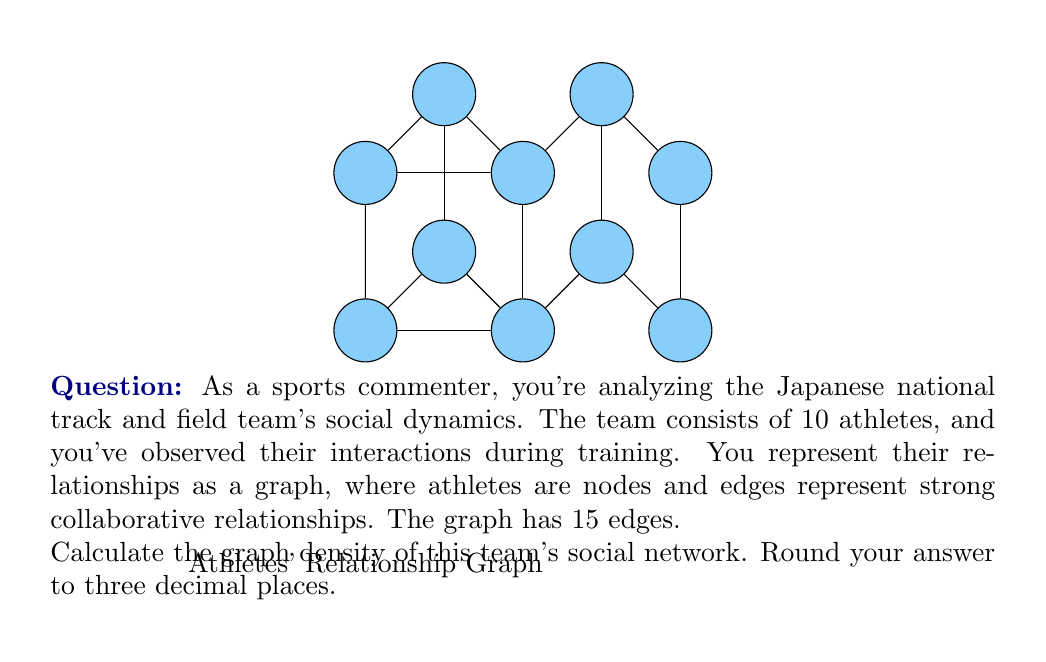Could you help me with this problem? To solve this problem, we need to understand and apply the concept of graph density in social network analysis. Let's break it down step-by-step:

1) Graph density is a measure of how many edges are in a graph compared to the maximum possible number of edges. It's calculated using the formula:

   $$D = \frac{2|E|}{|V|(|V|-1)}$$

   Where $|E|$ is the number of edges and $|V|$ is the number of vertices (nodes).

2) In this case:
   - Number of vertices $|V| = 10$ (athletes)
   - Number of edges $|E| = 15$ (relationships)

3) Let's substitute these values into the formula:

   $$D = \frac{2 * 15}{10 * (10-1)} = \frac{30}{10 * 9} = \frac{30}{90}$$

4) Simplify:
   
   $$D = \frac{1}{3} \approx 0.333$$

5) Rounding to three decimal places gives us 0.333.

This density value indicates that about 33.3% of all possible connections in the team are present, suggesting a moderately connected team.
Answer: 0.333 